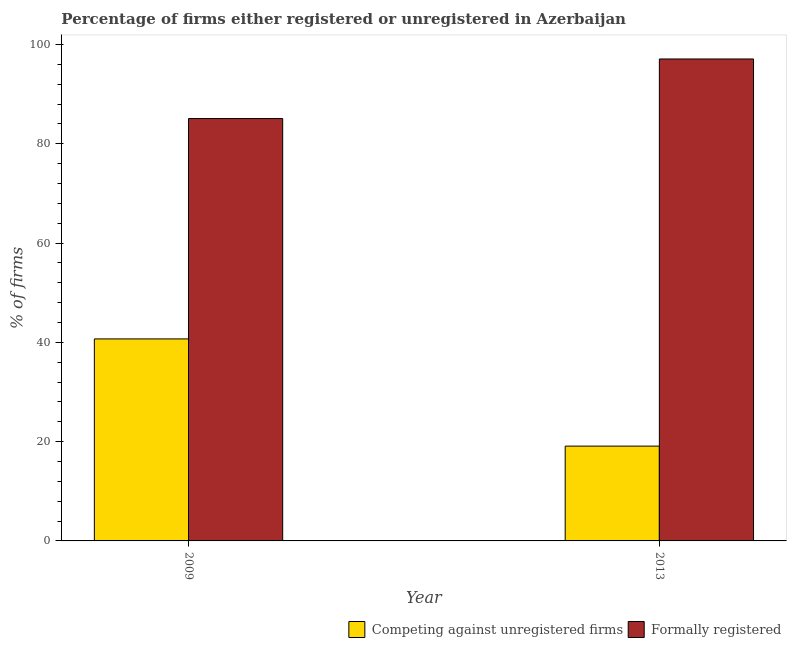Are the number of bars per tick equal to the number of legend labels?
Make the answer very short. Yes. How many bars are there on the 1st tick from the right?
Offer a very short reply. 2. What is the percentage of formally registered firms in 2009?
Offer a terse response. 85.1. Across all years, what is the maximum percentage of formally registered firms?
Your answer should be very brief. 97.1. In which year was the percentage of registered firms minimum?
Provide a succinct answer. 2013. What is the total percentage of registered firms in the graph?
Give a very brief answer. 59.8. What is the difference between the percentage of formally registered firms in 2009 and the percentage of registered firms in 2013?
Make the answer very short. -12. What is the average percentage of formally registered firms per year?
Ensure brevity in your answer.  91.1. In the year 2009, what is the difference between the percentage of registered firms and percentage of formally registered firms?
Keep it short and to the point. 0. In how many years, is the percentage of registered firms greater than 92 %?
Provide a short and direct response. 0. What is the ratio of the percentage of registered firms in 2009 to that in 2013?
Make the answer very short. 2.13. Is the percentage of formally registered firms in 2009 less than that in 2013?
Provide a succinct answer. Yes. In how many years, is the percentage of formally registered firms greater than the average percentage of formally registered firms taken over all years?
Provide a succinct answer. 1. What does the 1st bar from the left in 2013 represents?
Your answer should be very brief. Competing against unregistered firms. What does the 1st bar from the right in 2013 represents?
Provide a short and direct response. Formally registered. How many bars are there?
Offer a very short reply. 4. What is the difference between two consecutive major ticks on the Y-axis?
Provide a short and direct response. 20. Are the values on the major ticks of Y-axis written in scientific E-notation?
Make the answer very short. No. Does the graph contain any zero values?
Provide a succinct answer. No. Does the graph contain grids?
Provide a succinct answer. No. Where does the legend appear in the graph?
Your answer should be compact. Bottom right. How are the legend labels stacked?
Ensure brevity in your answer.  Horizontal. What is the title of the graph?
Keep it short and to the point. Percentage of firms either registered or unregistered in Azerbaijan. Does "Depositors" appear as one of the legend labels in the graph?
Give a very brief answer. No. What is the label or title of the X-axis?
Your answer should be very brief. Year. What is the label or title of the Y-axis?
Provide a succinct answer. % of firms. What is the % of firms in Competing against unregistered firms in 2009?
Your answer should be very brief. 40.7. What is the % of firms in Formally registered in 2009?
Your answer should be compact. 85.1. What is the % of firms of Formally registered in 2013?
Make the answer very short. 97.1. Across all years, what is the maximum % of firms in Competing against unregistered firms?
Your answer should be compact. 40.7. Across all years, what is the maximum % of firms of Formally registered?
Ensure brevity in your answer.  97.1. Across all years, what is the minimum % of firms in Competing against unregistered firms?
Ensure brevity in your answer.  19.1. Across all years, what is the minimum % of firms of Formally registered?
Give a very brief answer. 85.1. What is the total % of firms of Competing against unregistered firms in the graph?
Keep it short and to the point. 59.8. What is the total % of firms of Formally registered in the graph?
Give a very brief answer. 182.2. What is the difference between the % of firms of Competing against unregistered firms in 2009 and that in 2013?
Make the answer very short. 21.6. What is the difference between the % of firms in Formally registered in 2009 and that in 2013?
Make the answer very short. -12. What is the difference between the % of firms in Competing against unregistered firms in 2009 and the % of firms in Formally registered in 2013?
Give a very brief answer. -56.4. What is the average % of firms in Competing against unregistered firms per year?
Your answer should be compact. 29.9. What is the average % of firms in Formally registered per year?
Provide a succinct answer. 91.1. In the year 2009, what is the difference between the % of firms of Competing against unregistered firms and % of firms of Formally registered?
Your response must be concise. -44.4. In the year 2013, what is the difference between the % of firms in Competing against unregistered firms and % of firms in Formally registered?
Your answer should be very brief. -78. What is the ratio of the % of firms in Competing against unregistered firms in 2009 to that in 2013?
Offer a very short reply. 2.13. What is the ratio of the % of firms of Formally registered in 2009 to that in 2013?
Ensure brevity in your answer.  0.88. What is the difference between the highest and the second highest % of firms of Competing against unregistered firms?
Your response must be concise. 21.6. What is the difference between the highest and the second highest % of firms in Formally registered?
Your response must be concise. 12. What is the difference between the highest and the lowest % of firms in Competing against unregistered firms?
Offer a very short reply. 21.6. What is the difference between the highest and the lowest % of firms of Formally registered?
Offer a terse response. 12. 